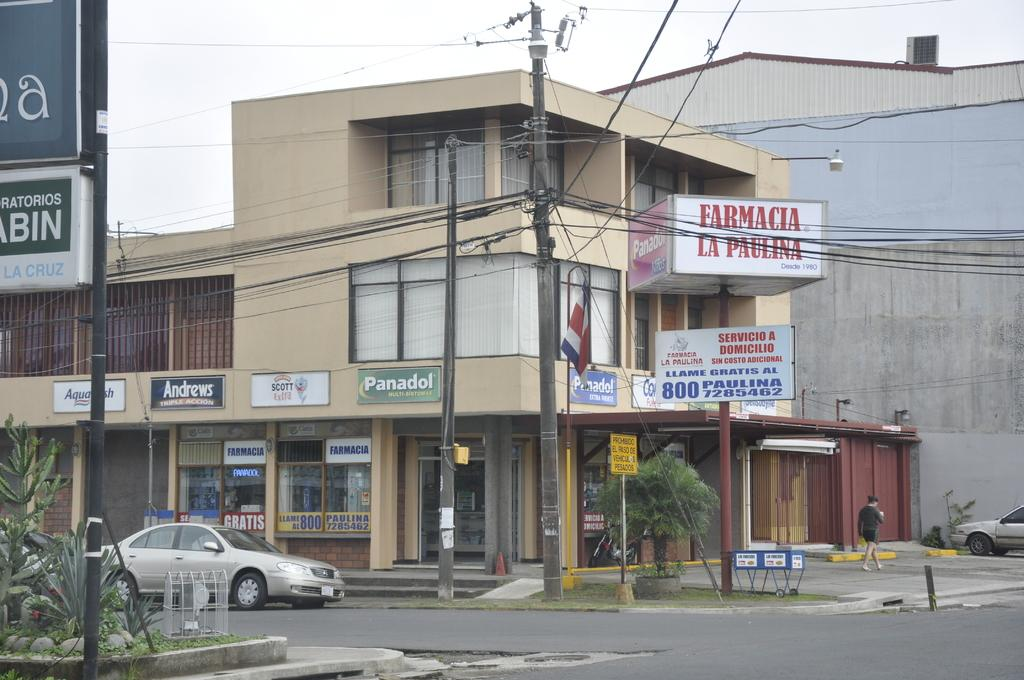What type of structures can be seen in the image? There are buildings in the image. What decorative elements are present in the image? There are banners in the image. What type of authority figure is present in the image? There is a police presence in the image. What mode of transportation can be seen in the image? There are cars in the image. What activity is a person engaged in within the image? There is a person walking in the image. What part of the natural environment is visible in the image? The sky is visible in the image. What type of test is being conducted in the image? There is no test being conducted in the image; it features buildings, banners, police presence, cars, a person walking, and a visible sky. What type of note is being played by the person walking in the image? There is no person playing a note in the image; the person is simply walking. 